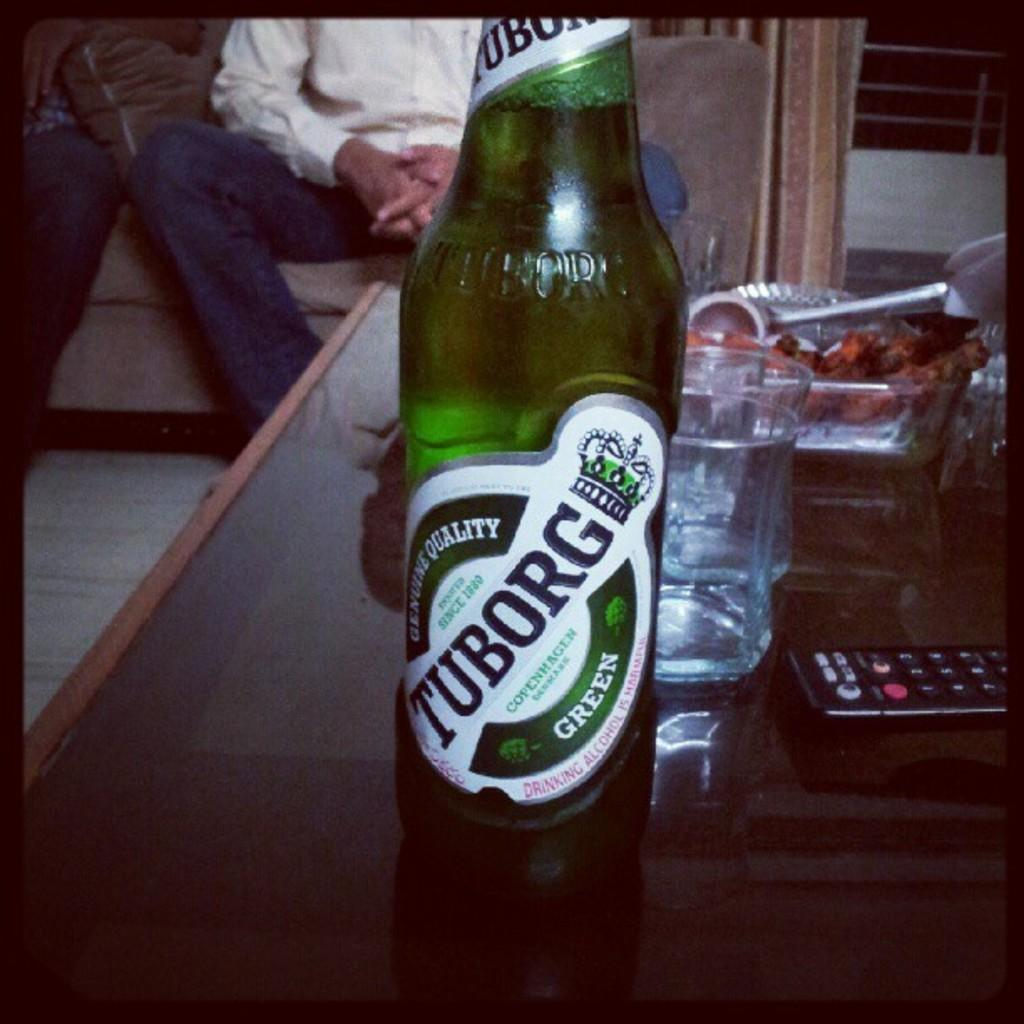<image>
Offer a succinct explanation of the picture presented. A green bottle of Tuborg beer sits on a coffee table. 